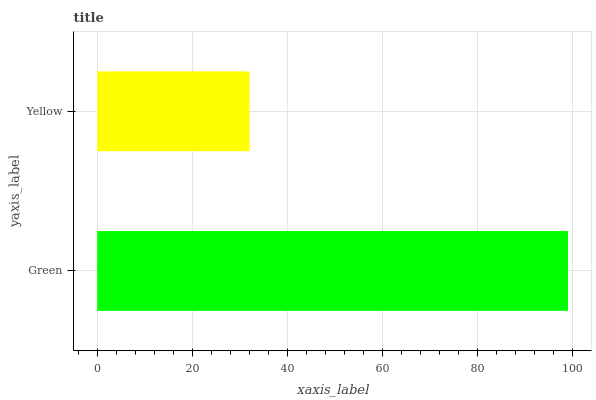Is Yellow the minimum?
Answer yes or no. Yes. Is Green the maximum?
Answer yes or no. Yes. Is Yellow the maximum?
Answer yes or no. No. Is Green greater than Yellow?
Answer yes or no. Yes. Is Yellow less than Green?
Answer yes or no. Yes. Is Yellow greater than Green?
Answer yes or no. No. Is Green less than Yellow?
Answer yes or no. No. Is Green the high median?
Answer yes or no. Yes. Is Yellow the low median?
Answer yes or no. Yes. Is Yellow the high median?
Answer yes or no. No. Is Green the low median?
Answer yes or no. No. 